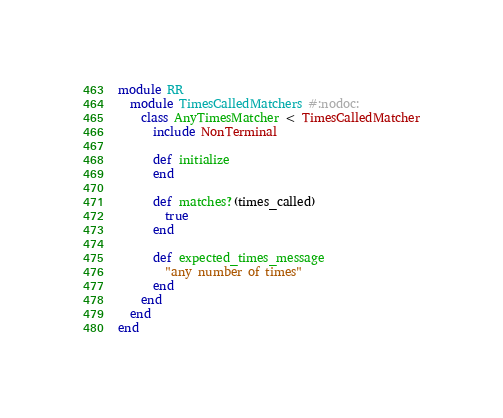<code> <loc_0><loc_0><loc_500><loc_500><_Ruby_>module RR
  module TimesCalledMatchers #:nodoc:
    class AnyTimesMatcher < TimesCalledMatcher
      include NonTerminal

      def initialize
      end

      def matches?(times_called)
        true
      end

      def expected_times_message
        "any number of times"
      end
    end
  end
end</code> 